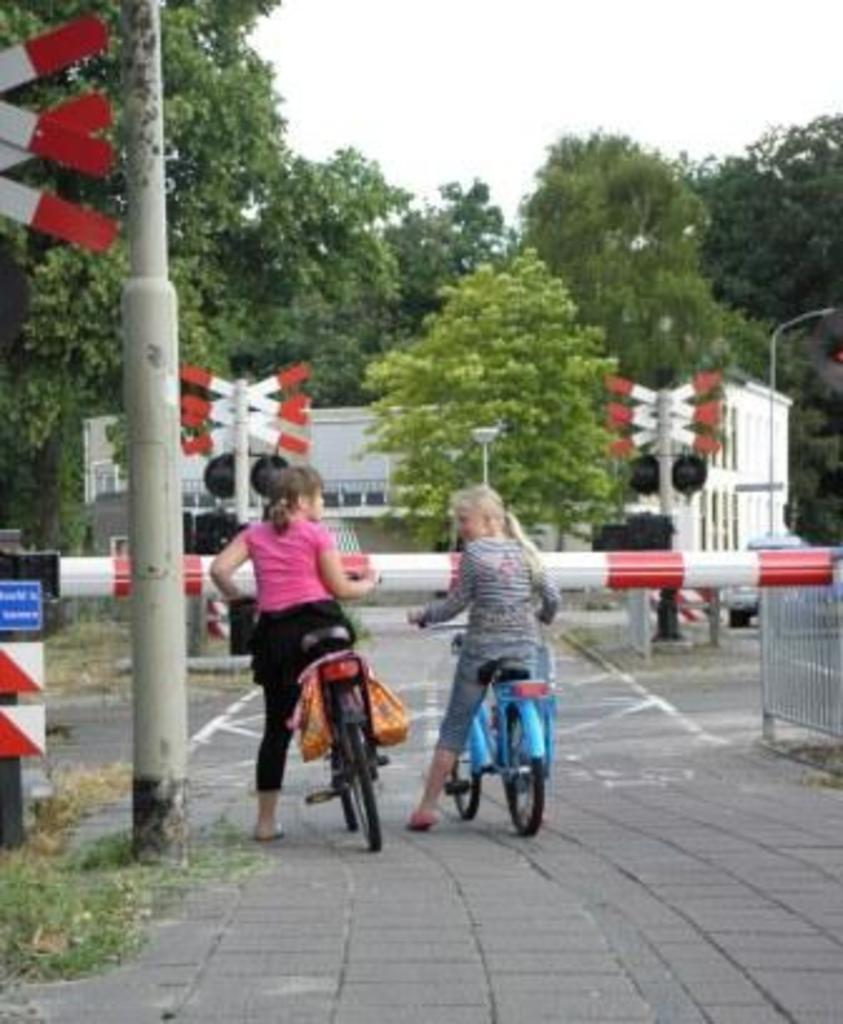How many girls are present in the image? There are 2 girls in the image. What are the girls doing in the image? The girls are with a cycle in the image. Where are the girls located in the image? They are on a path in the image. What can be seen in the background of the image? There is a pole, trees, and a building in the background of the image. What else is visible in the background of the image? There is a signal in the background of the image. What type of trade is being conducted between the girls in the image? There is no indication of any trade being conducted between the girls in the image. Can you read the note that one of the girls is holding in the image? There is no note visible in the image. 